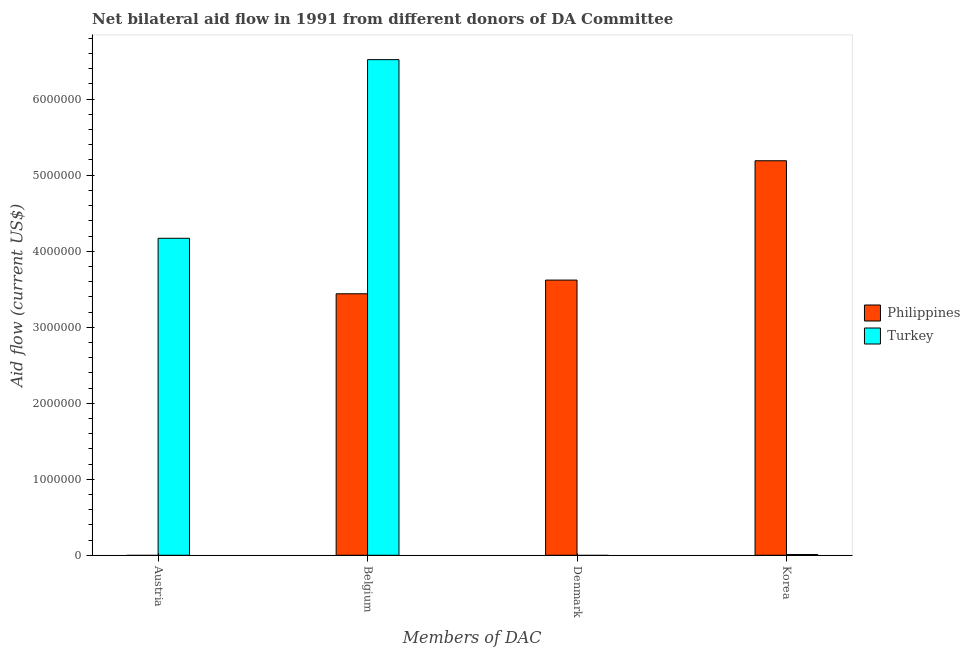Are the number of bars per tick equal to the number of legend labels?
Offer a very short reply. No. Are the number of bars on each tick of the X-axis equal?
Give a very brief answer. No. How many bars are there on the 2nd tick from the right?
Offer a very short reply. 1. What is the label of the 4th group of bars from the left?
Make the answer very short. Korea. What is the amount of aid given by belgium in Philippines?
Keep it short and to the point. 3.44e+06. Across all countries, what is the maximum amount of aid given by austria?
Provide a short and direct response. 4.17e+06. What is the total amount of aid given by denmark in the graph?
Keep it short and to the point. 3.62e+06. What is the difference between the amount of aid given by korea in Turkey and that in Philippines?
Make the answer very short. -5.18e+06. What is the difference between the amount of aid given by belgium in Turkey and the amount of aid given by korea in Philippines?
Provide a short and direct response. 1.33e+06. What is the average amount of aid given by austria per country?
Provide a succinct answer. 2.08e+06. What is the difference between the amount of aid given by austria and amount of aid given by belgium in Turkey?
Offer a very short reply. -2.35e+06. In how many countries, is the amount of aid given by belgium greater than 400000 US$?
Your answer should be compact. 2. What is the ratio of the amount of aid given by belgium in Turkey to that in Philippines?
Provide a succinct answer. 1.9. Is the amount of aid given by korea in Philippines less than that in Turkey?
Provide a short and direct response. No. What is the difference between the highest and the second highest amount of aid given by korea?
Your answer should be very brief. 5.18e+06. What is the difference between the highest and the lowest amount of aid given by austria?
Make the answer very short. 4.17e+06. Is it the case that in every country, the sum of the amount of aid given by korea and amount of aid given by belgium is greater than the sum of amount of aid given by austria and amount of aid given by denmark?
Ensure brevity in your answer.  Yes. Is it the case that in every country, the sum of the amount of aid given by austria and amount of aid given by belgium is greater than the amount of aid given by denmark?
Keep it short and to the point. No. How many bars are there?
Your answer should be compact. 6. Are all the bars in the graph horizontal?
Your answer should be compact. No. How many countries are there in the graph?
Ensure brevity in your answer.  2. Does the graph contain any zero values?
Keep it short and to the point. Yes. What is the title of the graph?
Make the answer very short. Net bilateral aid flow in 1991 from different donors of DA Committee. Does "East Asia (developing only)" appear as one of the legend labels in the graph?
Your response must be concise. No. What is the label or title of the X-axis?
Your answer should be very brief. Members of DAC. What is the label or title of the Y-axis?
Offer a very short reply. Aid flow (current US$). What is the Aid flow (current US$) of Turkey in Austria?
Offer a terse response. 4.17e+06. What is the Aid flow (current US$) in Philippines in Belgium?
Offer a very short reply. 3.44e+06. What is the Aid flow (current US$) of Turkey in Belgium?
Ensure brevity in your answer.  6.52e+06. What is the Aid flow (current US$) in Philippines in Denmark?
Your answer should be very brief. 3.62e+06. What is the Aid flow (current US$) in Turkey in Denmark?
Make the answer very short. 0. What is the Aid flow (current US$) in Philippines in Korea?
Keep it short and to the point. 5.19e+06. What is the Aid flow (current US$) of Turkey in Korea?
Give a very brief answer. 10000. Across all Members of DAC, what is the maximum Aid flow (current US$) of Philippines?
Keep it short and to the point. 5.19e+06. Across all Members of DAC, what is the maximum Aid flow (current US$) of Turkey?
Give a very brief answer. 6.52e+06. What is the total Aid flow (current US$) in Philippines in the graph?
Make the answer very short. 1.22e+07. What is the total Aid flow (current US$) in Turkey in the graph?
Make the answer very short. 1.07e+07. What is the difference between the Aid flow (current US$) of Turkey in Austria and that in Belgium?
Give a very brief answer. -2.35e+06. What is the difference between the Aid flow (current US$) of Turkey in Austria and that in Korea?
Ensure brevity in your answer.  4.16e+06. What is the difference between the Aid flow (current US$) of Philippines in Belgium and that in Korea?
Your answer should be very brief. -1.75e+06. What is the difference between the Aid flow (current US$) in Turkey in Belgium and that in Korea?
Keep it short and to the point. 6.51e+06. What is the difference between the Aid flow (current US$) in Philippines in Denmark and that in Korea?
Your answer should be compact. -1.57e+06. What is the difference between the Aid flow (current US$) in Philippines in Belgium and the Aid flow (current US$) in Turkey in Korea?
Provide a succinct answer. 3.43e+06. What is the difference between the Aid flow (current US$) in Philippines in Denmark and the Aid flow (current US$) in Turkey in Korea?
Your answer should be compact. 3.61e+06. What is the average Aid flow (current US$) of Philippines per Members of DAC?
Offer a very short reply. 3.06e+06. What is the average Aid flow (current US$) in Turkey per Members of DAC?
Provide a short and direct response. 2.68e+06. What is the difference between the Aid flow (current US$) of Philippines and Aid flow (current US$) of Turkey in Belgium?
Make the answer very short. -3.08e+06. What is the difference between the Aid flow (current US$) of Philippines and Aid flow (current US$) of Turkey in Korea?
Provide a short and direct response. 5.18e+06. What is the ratio of the Aid flow (current US$) in Turkey in Austria to that in Belgium?
Your answer should be very brief. 0.64. What is the ratio of the Aid flow (current US$) in Turkey in Austria to that in Korea?
Provide a succinct answer. 417. What is the ratio of the Aid flow (current US$) in Philippines in Belgium to that in Denmark?
Offer a very short reply. 0.95. What is the ratio of the Aid flow (current US$) of Philippines in Belgium to that in Korea?
Make the answer very short. 0.66. What is the ratio of the Aid flow (current US$) of Turkey in Belgium to that in Korea?
Ensure brevity in your answer.  652. What is the ratio of the Aid flow (current US$) in Philippines in Denmark to that in Korea?
Provide a short and direct response. 0.7. What is the difference between the highest and the second highest Aid flow (current US$) of Philippines?
Offer a terse response. 1.57e+06. What is the difference between the highest and the second highest Aid flow (current US$) in Turkey?
Your answer should be compact. 2.35e+06. What is the difference between the highest and the lowest Aid flow (current US$) of Philippines?
Your answer should be very brief. 5.19e+06. What is the difference between the highest and the lowest Aid flow (current US$) of Turkey?
Offer a terse response. 6.52e+06. 